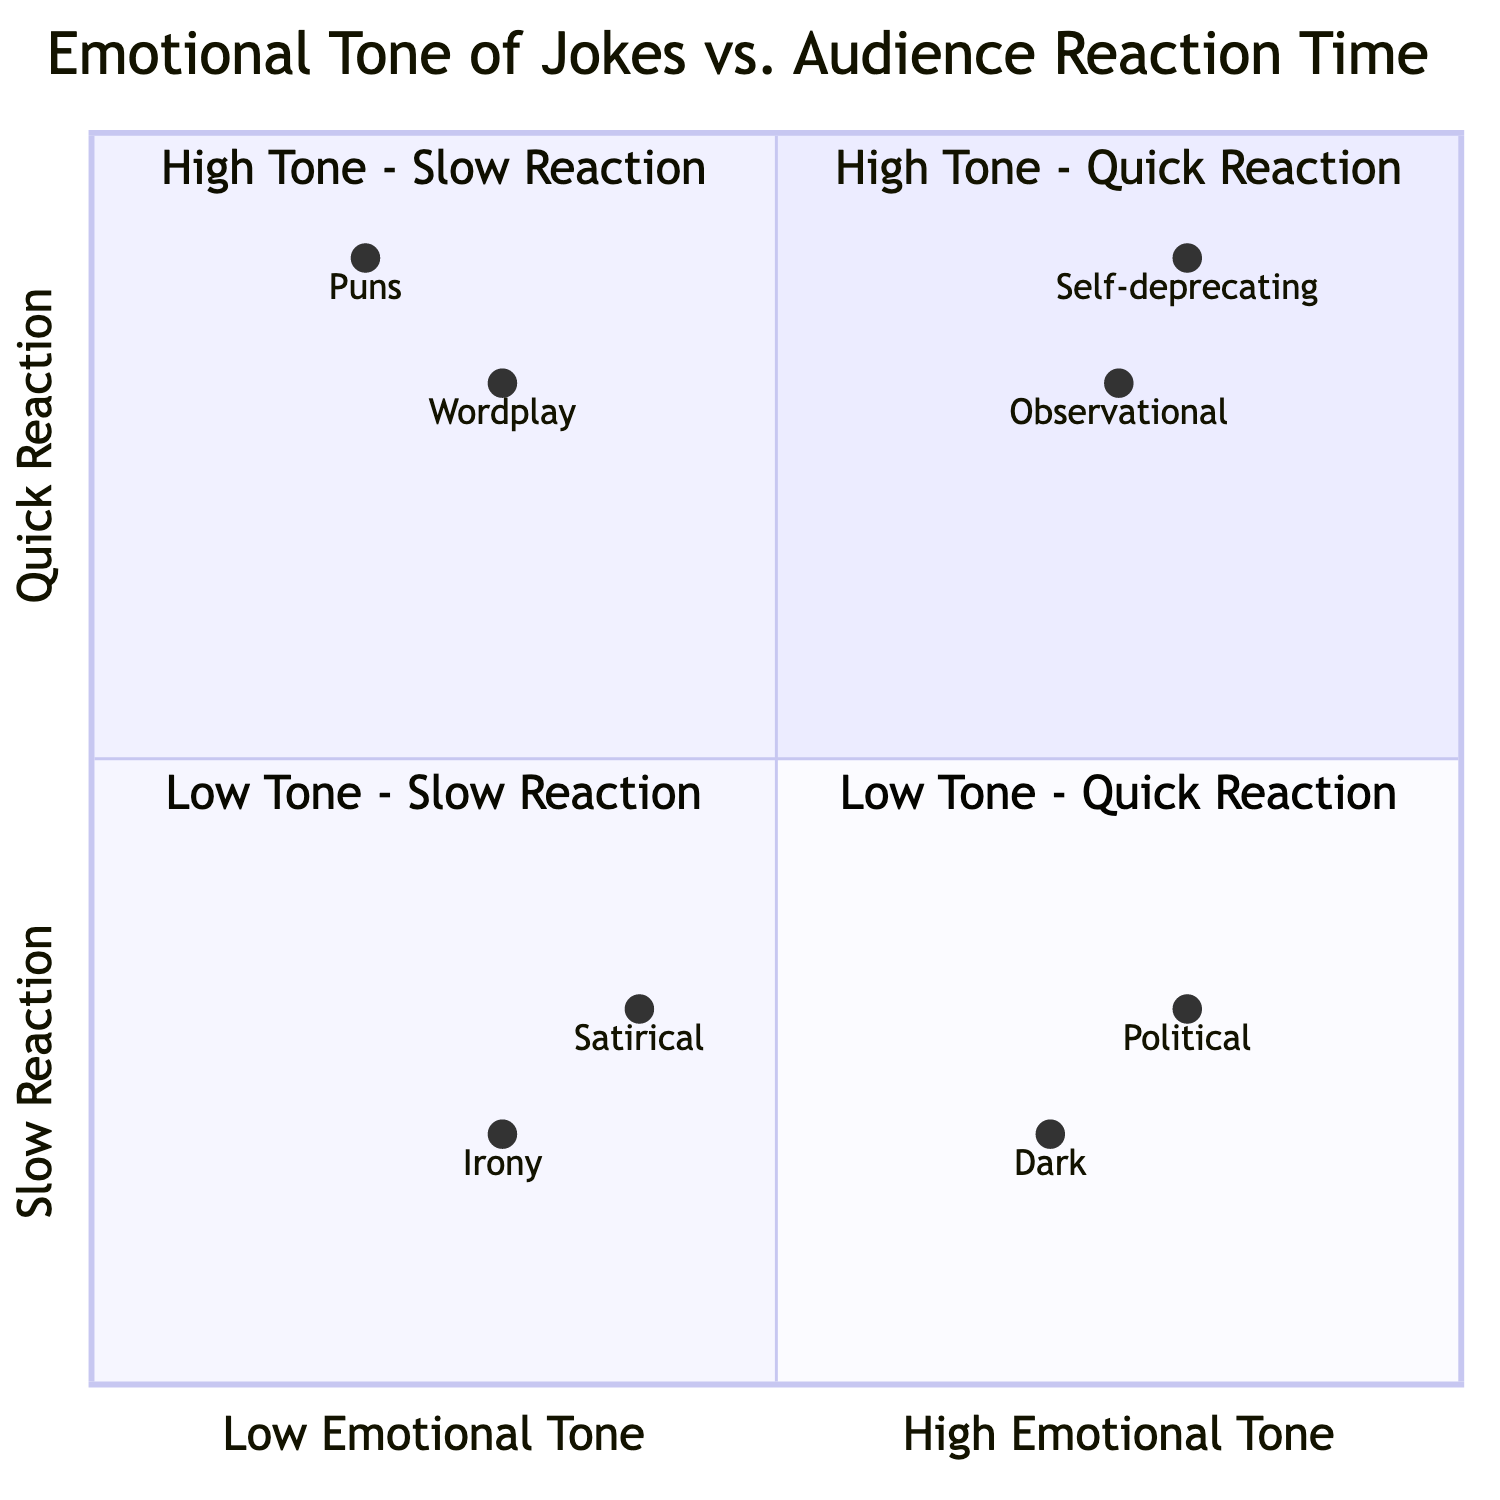What type of humor does Jerry Seinfeld use? In the quadrant labeled "High Emotional Tone - Quick Reaction," one of the examples provided is Jerry Seinfeld with "Observational Comedy," which represents a type of humor he is known for.
Answer: Observational Comedy How long does the audience take to react to Kevin Hart's joke? In the "High Emotional Tone - Quick Reaction" quadrant, it shows that the audience's reaction time to Kevin Hart’s "Self-deprecating Humor" is between 1-2 seconds.
Answer: 1-2 seconds Which comedian's joke elicits a reaction in 5-6 seconds? In the quadrant titled "High Emotional Tone - Slow Reaction," Anthony Jeselnik's "Dark Humor" has an audience reaction time listed as 5-6 seconds.
Answer: Anthony Jeselnik What is the emotional tone of Tig Notaro's joke? Tig Notaro is featured in the "Low Emotional Tone - Slow Reaction" quadrant, where her joke is labeled as "Irony," indicating a low emotional tone.
Answer: Low Emotional Tone Which quadrant contains puns and how long is the audience reaction time? The "Low Emotional Tone - Quick Reaction" quadrant includes Demetri Martin's "Puns," with an audience reaction time of 1-2 seconds.
Answer: Low Emotional Tone - Quick Reaction, 1-2 seconds How many humor types result in quick reactions? By surveying the "High Emotional Tone - Quick Reaction" and "Low Emotional Tone - Quick Reaction" quadrants, we can identify four humor types: "Observational Comedy," "Self-deprecating Humor," "Puns," and "Wordplay." So, there are four humor types that result in quick reactions.
Answer: Four Which two jokes have the slowest audience reaction time? In the quadrants with slow reactions, "Dark Humor" by Anthony Jeselnik and "Irony" by Tig Notaro both have reaction times of 5-6 seconds and 5-6 seconds, respectively.
Answer: Dark Humor, Irony What can be inferred about audience reactions to political satire? John Oliver's "Political Satire" is found in the "High Emotional Tone - Slow Reaction" quadrant, indicating that even though it's a high emotional tone, audience reactions take 4-5 seconds. This suggests that more complex themes may take longer to process.
Answer: Slow Reaction Which quadrant has examples with wordplay and irony? "Wordplay" by Steven Wright is in the "Low Emotional Tone - Quick Reaction" quadrant, while "Irony" by Tig Notaro appears in the "Low Emotional Tone - Slow Reaction" quadrant. Both are categorized under low emotional tone but are positioned in different quadrants based on reaction time.
Answer: Low Emotional Tone - Quick Reaction and Low Emotional Tone - Slow Reaction 